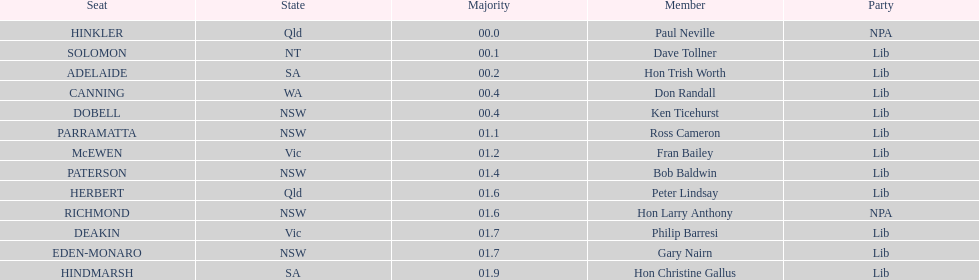What is the sum of seats? 13. 